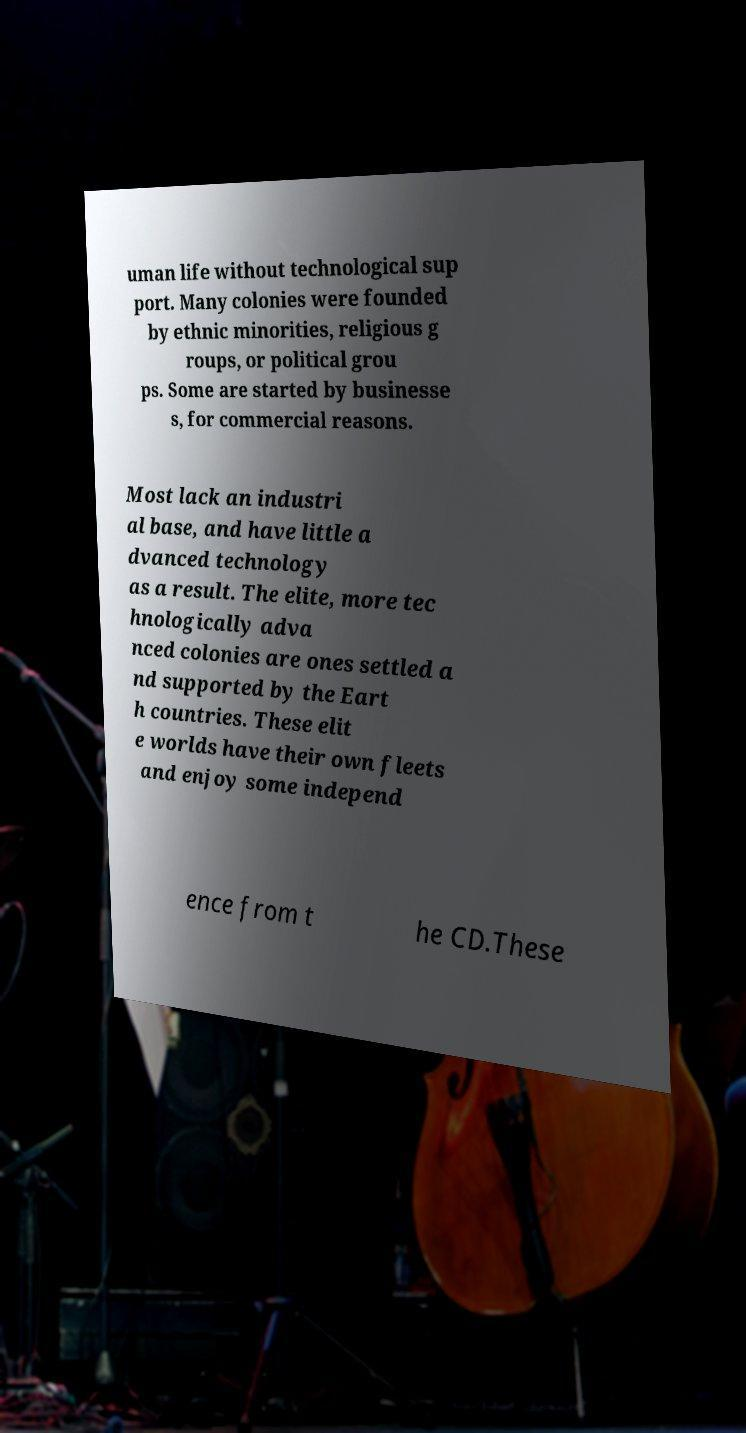What messages or text are displayed in this image? I need them in a readable, typed format. uman life without technological sup port. Many colonies were founded by ethnic minorities, religious g roups, or political grou ps. Some are started by businesse s, for commercial reasons. Most lack an industri al base, and have little a dvanced technology as a result. The elite, more tec hnologically adva nced colonies are ones settled a nd supported by the Eart h countries. These elit e worlds have their own fleets and enjoy some independ ence from t he CD.These 